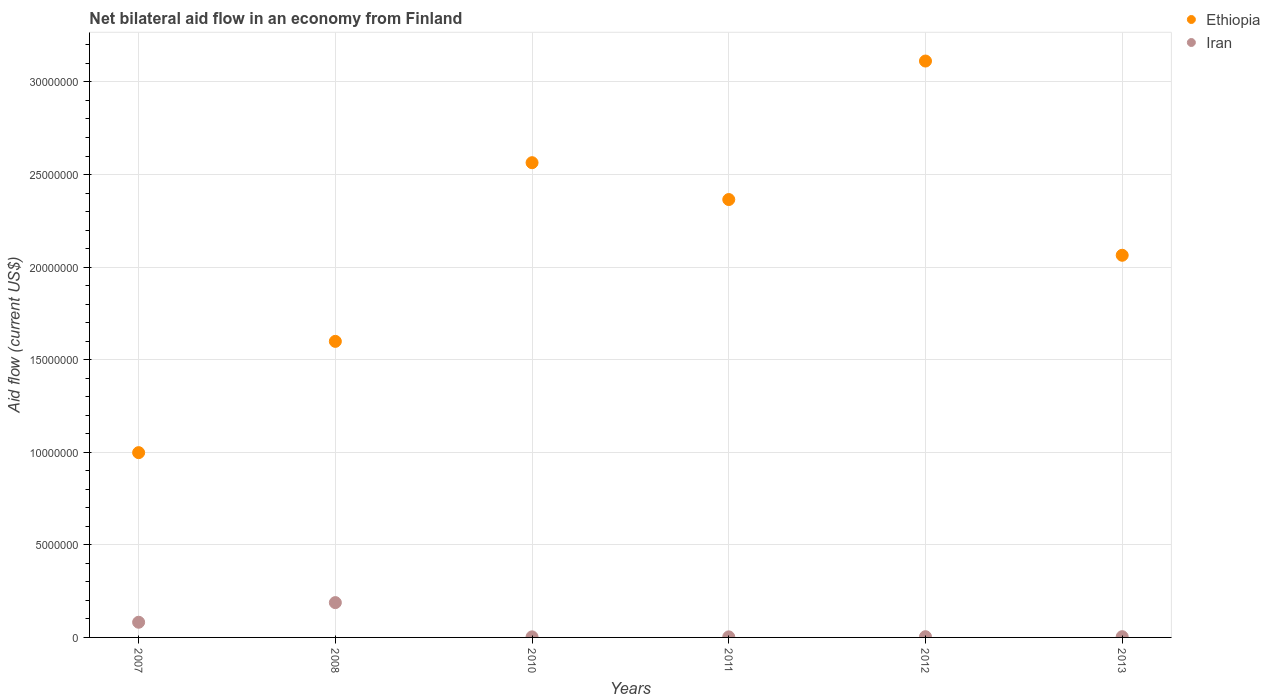How many different coloured dotlines are there?
Offer a terse response. 2. Is the number of dotlines equal to the number of legend labels?
Your answer should be compact. Yes. What is the net bilateral aid flow in Ethiopia in 2010?
Give a very brief answer. 2.56e+07. Across all years, what is the maximum net bilateral aid flow in Iran?
Your answer should be compact. 1.88e+06. Across all years, what is the minimum net bilateral aid flow in Ethiopia?
Ensure brevity in your answer.  9.98e+06. In which year was the net bilateral aid flow in Iran maximum?
Offer a very short reply. 2008. In which year was the net bilateral aid flow in Ethiopia minimum?
Ensure brevity in your answer.  2007. What is the total net bilateral aid flow in Ethiopia in the graph?
Make the answer very short. 1.27e+08. What is the difference between the net bilateral aid flow in Iran in 2007 and that in 2010?
Offer a very short reply. 7.90e+05. What is the difference between the net bilateral aid flow in Iran in 2007 and the net bilateral aid flow in Ethiopia in 2012?
Ensure brevity in your answer.  -3.03e+07. What is the average net bilateral aid flow in Iran per year?
Your response must be concise. 4.73e+05. In the year 2013, what is the difference between the net bilateral aid flow in Ethiopia and net bilateral aid flow in Iran?
Offer a very short reply. 2.06e+07. In how many years, is the net bilateral aid flow in Ethiopia greater than 16000000 US$?
Offer a very short reply. 4. What is the ratio of the net bilateral aid flow in Iran in 2008 to that in 2010?
Your answer should be very brief. 62.67. Is the net bilateral aid flow in Iran in 2007 less than that in 2011?
Your answer should be very brief. No. Is the difference between the net bilateral aid flow in Ethiopia in 2012 and 2013 greater than the difference between the net bilateral aid flow in Iran in 2012 and 2013?
Ensure brevity in your answer.  Yes. What is the difference between the highest and the second highest net bilateral aid flow in Ethiopia?
Keep it short and to the point. 5.49e+06. What is the difference between the highest and the lowest net bilateral aid flow in Ethiopia?
Offer a very short reply. 2.12e+07. In how many years, is the net bilateral aid flow in Iran greater than the average net bilateral aid flow in Iran taken over all years?
Keep it short and to the point. 2. Is the sum of the net bilateral aid flow in Iran in 2007 and 2011 greater than the maximum net bilateral aid flow in Ethiopia across all years?
Give a very brief answer. No. Is the net bilateral aid flow in Iran strictly greater than the net bilateral aid flow in Ethiopia over the years?
Your answer should be very brief. No. Is the net bilateral aid flow in Ethiopia strictly less than the net bilateral aid flow in Iran over the years?
Offer a terse response. No. How many dotlines are there?
Give a very brief answer. 2. Are the values on the major ticks of Y-axis written in scientific E-notation?
Make the answer very short. No. Does the graph contain any zero values?
Your response must be concise. No. Does the graph contain grids?
Offer a very short reply. Yes. Where does the legend appear in the graph?
Provide a succinct answer. Top right. How many legend labels are there?
Give a very brief answer. 2. What is the title of the graph?
Offer a very short reply. Net bilateral aid flow in an economy from Finland. Does "Sudan" appear as one of the legend labels in the graph?
Your answer should be compact. No. What is the label or title of the Y-axis?
Your answer should be very brief. Aid flow (current US$). What is the Aid flow (current US$) of Ethiopia in 2007?
Give a very brief answer. 9.98e+06. What is the Aid flow (current US$) in Iran in 2007?
Provide a short and direct response. 8.20e+05. What is the Aid flow (current US$) in Ethiopia in 2008?
Your response must be concise. 1.60e+07. What is the Aid flow (current US$) in Iran in 2008?
Keep it short and to the point. 1.88e+06. What is the Aid flow (current US$) in Ethiopia in 2010?
Keep it short and to the point. 2.56e+07. What is the Aid flow (current US$) in Ethiopia in 2011?
Your answer should be compact. 2.36e+07. What is the Aid flow (current US$) of Iran in 2011?
Your answer should be compact. 3.00e+04. What is the Aid flow (current US$) in Ethiopia in 2012?
Give a very brief answer. 3.11e+07. What is the Aid flow (current US$) in Ethiopia in 2013?
Keep it short and to the point. 2.06e+07. Across all years, what is the maximum Aid flow (current US$) in Ethiopia?
Your answer should be very brief. 3.11e+07. Across all years, what is the maximum Aid flow (current US$) of Iran?
Your response must be concise. 1.88e+06. Across all years, what is the minimum Aid flow (current US$) in Ethiopia?
Give a very brief answer. 9.98e+06. Across all years, what is the minimum Aid flow (current US$) of Iran?
Offer a very short reply. 3.00e+04. What is the total Aid flow (current US$) in Ethiopia in the graph?
Your answer should be very brief. 1.27e+08. What is the total Aid flow (current US$) in Iran in the graph?
Keep it short and to the point. 2.84e+06. What is the difference between the Aid flow (current US$) in Ethiopia in 2007 and that in 2008?
Keep it short and to the point. -6.01e+06. What is the difference between the Aid flow (current US$) in Iran in 2007 and that in 2008?
Ensure brevity in your answer.  -1.06e+06. What is the difference between the Aid flow (current US$) of Ethiopia in 2007 and that in 2010?
Offer a very short reply. -1.57e+07. What is the difference between the Aid flow (current US$) of Iran in 2007 and that in 2010?
Your answer should be compact. 7.90e+05. What is the difference between the Aid flow (current US$) of Ethiopia in 2007 and that in 2011?
Your answer should be very brief. -1.37e+07. What is the difference between the Aid flow (current US$) in Iran in 2007 and that in 2011?
Keep it short and to the point. 7.90e+05. What is the difference between the Aid flow (current US$) in Ethiopia in 2007 and that in 2012?
Your answer should be very brief. -2.12e+07. What is the difference between the Aid flow (current US$) of Iran in 2007 and that in 2012?
Your answer should be very brief. 7.80e+05. What is the difference between the Aid flow (current US$) of Ethiopia in 2007 and that in 2013?
Your response must be concise. -1.07e+07. What is the difference between the Aid flow (current US$) of Iran in 2007 and that in 2013?
Offer a very short reply. 7.80e+05. What is the difference between the Aid flow (current US$) of Ethiopia in 2008 and that in 2010?
Provide a short and direct response. -9.65e+06. What is the difference between the Aid flow (current US$) of Iran in 2008 and that in 2010?
Keep it short and to the point. 1.85e+06. What is the difference between the Aid flow (current US$) of Ethiopia in 2008 and that in 2011?
Ensure brevity in your answer.  -7.66e+06. What is the difference between the Aid flow (current US$) in Iran in 2008 and that in 2011?
Provide a short and direct response. 1.85e+06. What is the difference between the Aid flow (current US$) of Ethiopia in 2008 and that in 2012?
Your answer should be compact. -1.51e+07. What is the difference between the Aid flow (current US$) of Iran in 2008 and that in 2012?
Your answer should be compact. 1.84e+06. What is the difference between the Aid flow (current US$) of Ethiopia in 2008 and that in 2013?
Make the answer very short. -4.65e+06. What is the difference between the Aid flow (current US$) of Iran in 2008 and that in 2013?
Make the answer very short. 1.84e+06. What is the difference between the Aid flow (current US$) in Ethiopia in 2010 and that in 2011?
Make the answer very short. 1.99e+06. What is the difference between the Aid flow (current US$) in Ethiopia in 2010 and that in 2012?
Make the answer very short. -5.49e+06. What is the difference between the Aid flow (current US$) in Iran in 2010 and that in 2013?
Offer a terse response. -10000. What is the difference between the Aid flow (current US$) in Ethiopia in 2011 and that in 2012?
Offer a terse response. -7.48e+06. What is the difference between the Aid flow (current US$) in Ethiopia in 2011 and that in 2013?
Give a very brief answer. 3.01e+06. What is the difference between the Aid flow (current US$) in Ethiopia in 2012 and that in 2013?
Give a very brief answer. 1.05e+07. What is the difference between the Aid flow (current US$) in Iran in 2012 and that in 2013?
Your answer should be very brief. 0. What is the difference between the Aid flow (current US$) of Ethiopia in 2007 and the Aid flow (current US$) of Iran in 2008?
Ensure brevity in your answer.  8.10e+06. What is the difference between the Aid flow (current US$) of Ethiopia in 2007 and the Aid flow (current US$) of Iran in 2010?
Give a very brief answer. 9.95e+06. What is the difference between the Aid flow (current US$) in Ethiopia in 2007 and the Aid flow (current US$) in Iran in 2011?
Ensure brevity in your answer.  9.95e+06. What is the difference between the Aid flow (current US$) in Ethiopia in 2007 and the Aid flow (current US$) in Iran in 2012?
Your answer should be compact. 9.94e+06. What is the difference between the Aid flow (current US$) in Ethiopia in 2007 and the Aid flow (current US$) in Iran in 2013?
Keep it short and to the point. 9.94e+06. What is the difference between the Aid flow (current US$) in Ethiopia in 2008 and the Aid flow (current US$) in Iran in 2010?
Your answer should be very brief. 1.60e+07. What is the difference between the Aid flow (current US$) of Ethiopia in 2008 and the Aid flow (current US$) of Iran in 2011?
Provide a short and direct response. 1.60e+07. What is the difference between the Aid flow (current US$) of Ethiopia in 2008 and the Aid flow (current US$) of Iran in 2012?
Offer a terse response. 1.60e+07. What is the difference between the Aid flow (current US$) of Ethiopia in 2008 and the Aid flow (current US$) of Iran in 2013?
Offer a terse response. 1.60e+07. What is the difference between the Aid flow (current US$) of Ethiopia in 2010 and the Aid flow (current US$) of Iran in 2011?
Your response must be concise. 2.56e+07. What is the difference between the Aid flow (current US$) of Ethiopia in 2010 and the Aid flow (current US$) of Iran in 2012?
Ensure brevity in your answer.  2.56e+07. What is the difference between the Aid flow (current US$) in Ethiopia in 2010 and the Aid flow (current US$) in Iran in 2013?
Give a very brief answer. 2.56e+07. What is the difference between the Aid flow (current US$) of Ethiopia in 2011 and the Aid flow (current US$) of Iran in 2012?
Keep it short and to the point. 2.36e+07. What is the difference between the Aid flow (current US$) in Ethiopia in 2011 and the Aid flow (current US$) in Iran in 2013?
Make the answer very short. 2.36e+07. What is the difference between the Aid flow (current US$) in Ethiopia in 2012 and the Aid flow (current US$) in Iran in 2013?
Give a very brief answer. 3.11e+07. What is the average Aid flow (current US$) in Ethiopia per year?
Give a very brief answer. 2.12e+07. What is the average Aid flow (current US$) in Iran per year?
Provide a succinct answer. 4.73e+05. In the year 2007, what is the difference between the Aid flow (current US$) of Ethiopia and Aid flow (current US$) of Iran?
Give a very brief answer. 9.16e+06. In the year 2008, what is the difference between the Aid flow (current US$) of Ethiopia and Aid flow (current US$) of Iran?
Make the answer very short. 1.41e+07. In the year 2010, what is the difference between the Aid flow (current US$) in Ethiopia and Aid flow (current US$) in Iran?
Your answer should be compact. 2.56e+07. In the year 2011, what is the difference between the Aid flow (current US$) in Ethiopia and Aid flow (current US$) in Iran?
Your response must be concise. 2.36e+07. In the year 2012, what is the difference between the Aid flow (current US$) in Ethiopia and Aid flow (current US$) in Iran?
Keep it short and to the point. 3.11e+07. In the year 2013, what is the difference between the Aid flow (current US$) of Ethiopia and Aid flow (current US$) of Iran?
Ensure brevity in your answer.  2.06e+07. What is the ratio of the Aid flow (current US$) of Ethiopia in 2007 to that in 2008?
Ensure brevity in your answer.  0.62. What is the ratio of the Aid flow (current US$) of Iran in 2007 to that in 2008?
Offer a terse response. 0.44. What is the ratio of the Aid flow (current US$) of Ethiopia in 2007 to that in 2010?
Ensure brevity in your answer.  0.39. What is the ratio of the Aid flow (current US$) of Iran in 2007 to that in 2010?
Provide a succinct answer. 27.33. What is the ratio of the Aid flow (current US$) of Ethiopia in 2007 to that in 2011?
Your answer should be very brief. 0.42. What is the ratio of the Aid flow (current US$) in Iran in 2007 to that in 2011?
Your answer should be compact. 27.33. What is the ratio of the Aid flow (current US$) in Ethiopia in 2007 to that in 2012?
Your response must be concise. 0.32. What is the ratio of the Aid flow (current US$) of Iran in 2007 to that in 2012?
Your response must be concise. 20.5. What is the ratio of the Aid flow (current US$) in Ethiopia in 2007 to that in 2013?
Offer a very short reply. 0.48. What is the ratio of the Aid flow (current US$) in Ethiopia in 2008 to that in 2010?
Keep it short and to the point. 0.62. What is the ratio of the Aid flow (current US$) in Iran in 2008 to that in 2010?
Offer a terse response. 62.67. What is the ratio of the Aid flow (current US$) of Ethiopia in 2008 to that in 2011?
Provide a short and direct response. 0.68. What is the ratio of the Aid flow (current US$) in Iran in 2008 to that in 2011?
Give a very brief answer. 62.67. What is the ratio of the Aid flow (current US$) in Ethiopia in 2008 to that in 2012?
Your answer should be compact. 0.51. What is the ratio of the Aid flow (current US$) in Ethiopia in 2008 to that in 2013?
Offer a very short reply. 0.77. What is the ratio of the Aid flow (current US$) in Ethiopia in 2010 to that in 2011?
Provide a succinct answer. 1.08. What is the ratio of the Aid flow (current US$) in Iran in 2010 to that in 2011?
Offer a very short reply. 1. What is the ratio of the Aid flow (current US$) in Ethiopia in 2010 to that in 2012?
Your answer should be very brief. 0.82. What is the ratio of the Aid flow (current US$) in Iran in 2010 to that in 2012?
Ensure brevity in your answer.  0.75. What is the ratio of the Aid flow (current US$) in Ethiopia in 2010 to that in 2013?
Provide a succinct answer. 1.24. What is the ratio of the Aid flow (current US$) in Iran in 2010 to that in 2013?
Keep it short and to the point. 0.75. What is the ratio of the Aid flow (current US$) of Ethiopia in 2011 to that in 2012?
Give a very brief answer. 0.76. What is the ratio of the Aid flow (current US$) of Ethiopia in 2011 to that in 2013?
Ensure brevity in your answer.  1.15. What is the ratio of the Aid flow (current US$) in Ethiopia in 2012 to that in 2013?
Ensure brevity in your answer.  1.51. What is the difference between the highest and the second highest Aid flow (current US$) in Ethiopia?
Give a very brief answer. 5.49e+06. What is the difference between the highest and the second highest Aid flow (current US$) of Iran?
Keep it short and to the point. 1.06e+06. What is the difference between the highest and the lowest Aid flow (current US$) in Ethiopia?
Ensure brevity in your answer.  2.12e+07. What is the difference between the highest and the lowest Aid flow (current US$) in Iran?
Your answer should be very brief. 1.85e+06. 